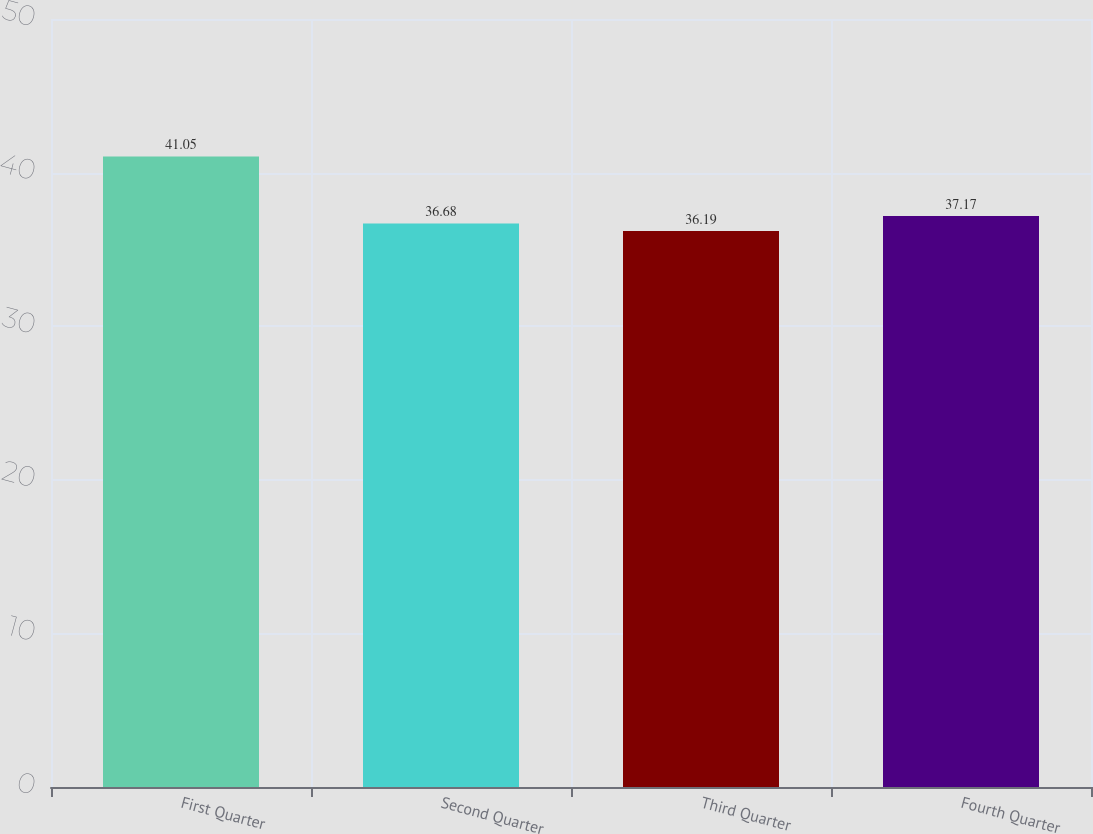Convert chart to OTSL. <chart><loc_0><loc_0><loc_500><loc_500><bar_chart><fcel>First Quarter<fcel>Second Quarter<fcel>Third Quarter<fcel>Fourth Quarter<nl><fcel>41.05<fcel>36.68<fcel>36.19<fcel>37.17<nl></chart> 